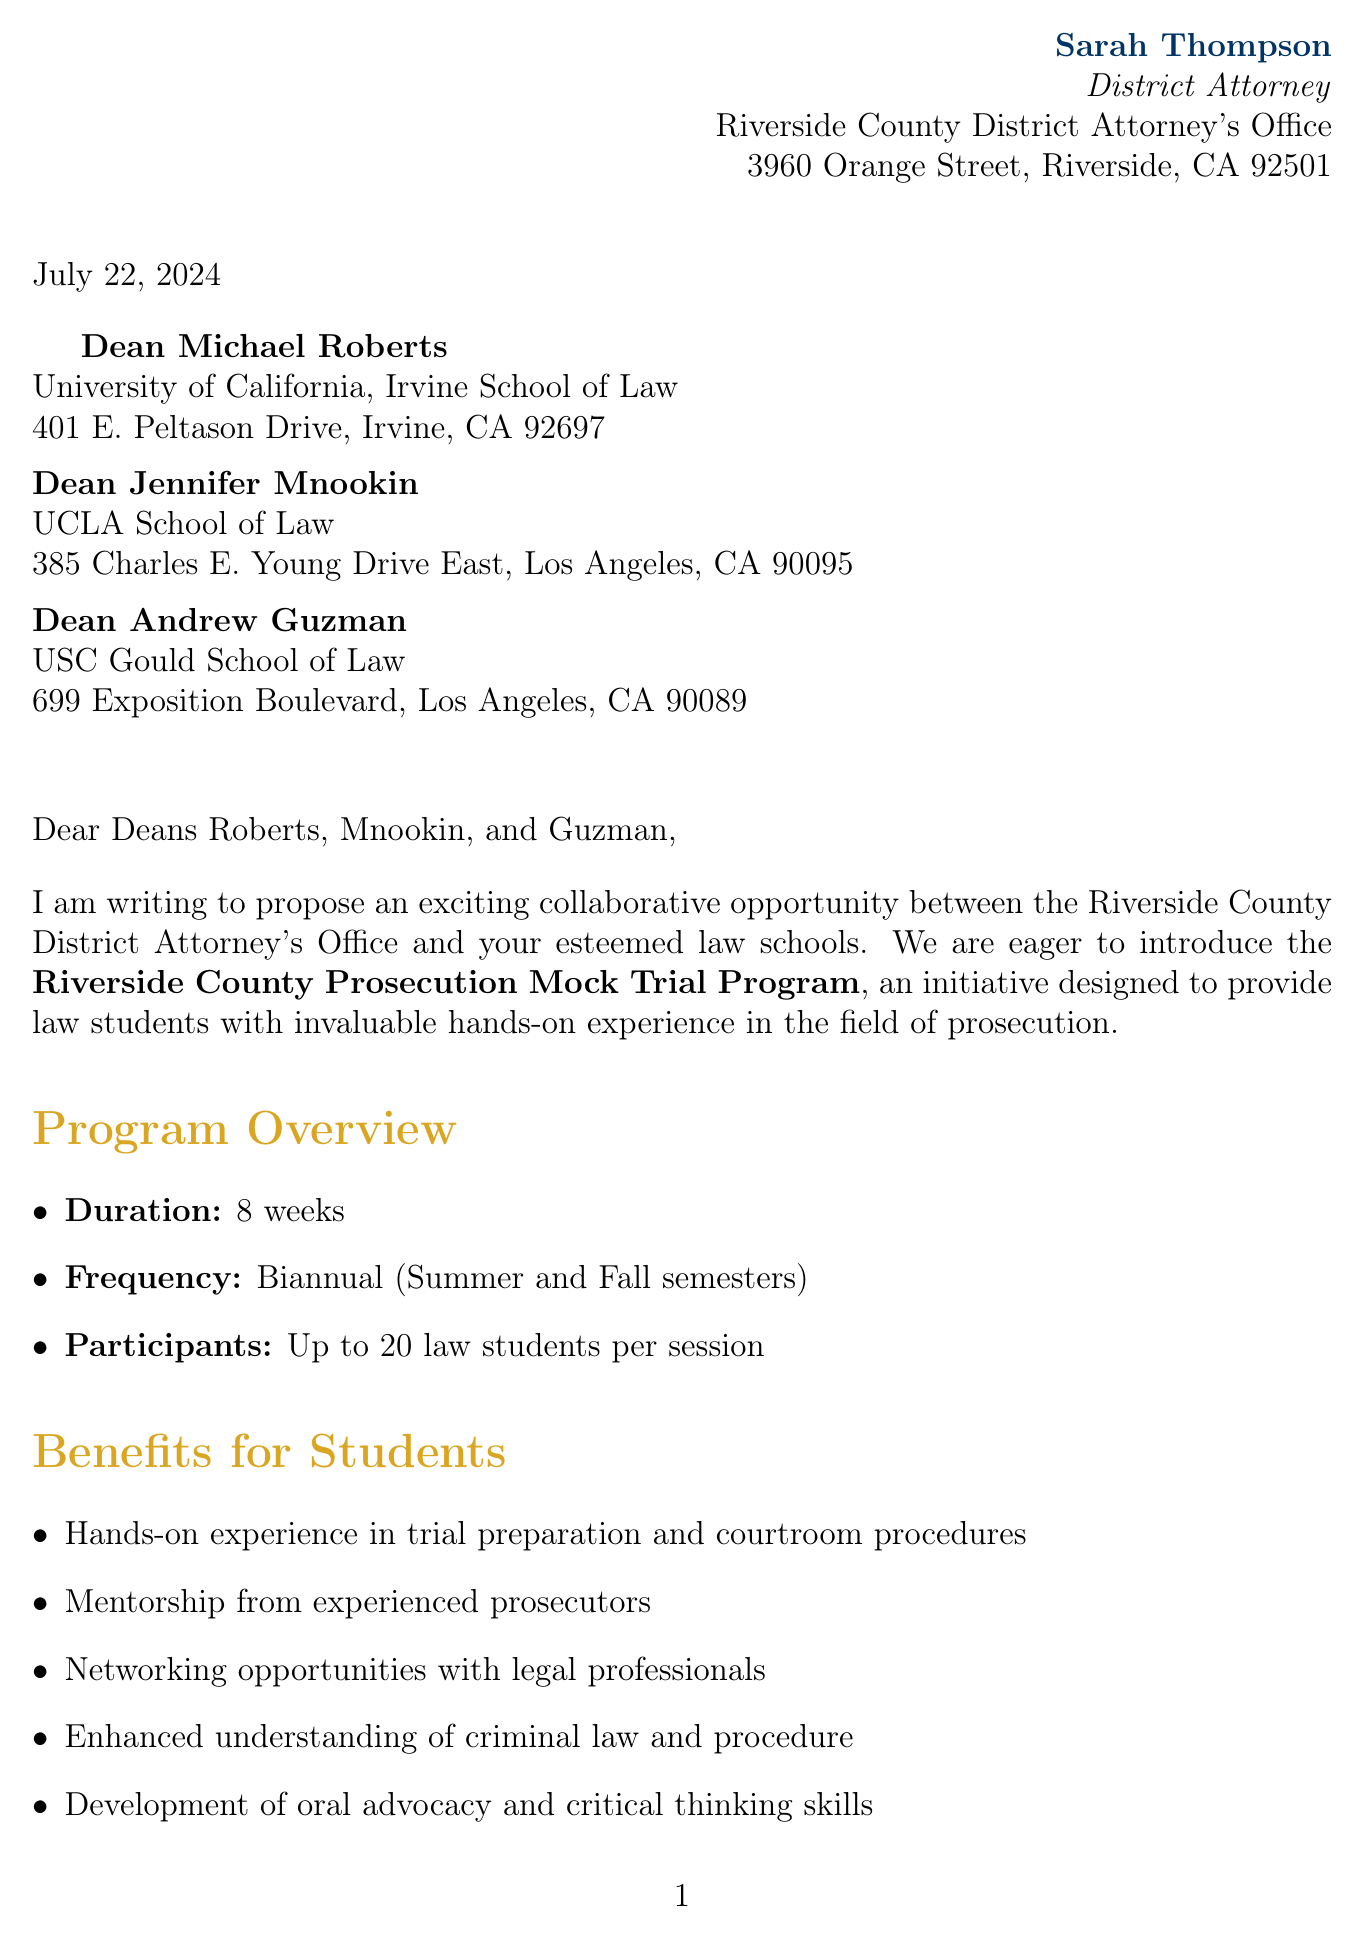What is the name of the program? The name of the program outlined in the document is prominently mentioned as “Riverside County Prosecution Mock Trial Program.”
Answer: Riverside County Prosecution Mock Trial Program Who is the sender of the letter? Sarah Thompson is identified as the sender of the letter with the title of District Attorney.
Answer: Sarah Thompson How many law students will participate per session? The document specifies that the program will accommodate “up to 20 law students per session.”
Answer: Up to 20 law students What is the duration of the program? The letter states that the program will last for “8 weeks.”
Answer: 8 weeks What is the proposed timeline for the pilot program? The document mentions that the pilot program is planned for the "Next Summer semester."
Answer: Next Summer semester How many hours are the weekly sessions? The letter specifies that the weekly sessions will be “4 hours each.”
Answer: 4 hours What are the faculty members' roles in the program? The document describes faculty involvement as serving "as advisors and evaluators."
Answer: Advisors and evaluators What is the location of the program? The program will take place at the "Riverside County Superior Court," according to the letter.
Answer: Riverside County Superior Court What kind of feedback system is proposed for the program? The document outlines a "bi-directional feedback system for continuous program improvement."
Answer: Bi-directional feedback system 